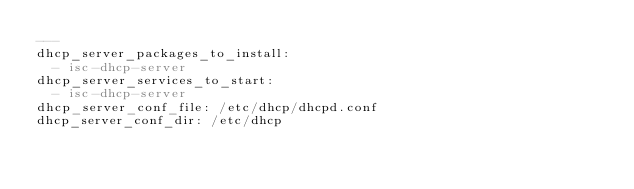<code> <loc_0><loc_0><loc_500><loc_500><_YAML_>---
dhcp_server_packages_to_install:
  - isc-dhcp-server
dhcp_server_services_to_start:
  - isc-dhcp-server
dhcp_server_conf_file: /etc/dhcp/dhcpd.conf
dhcp_server_conf_dir: /etc/dhcp
</code> 